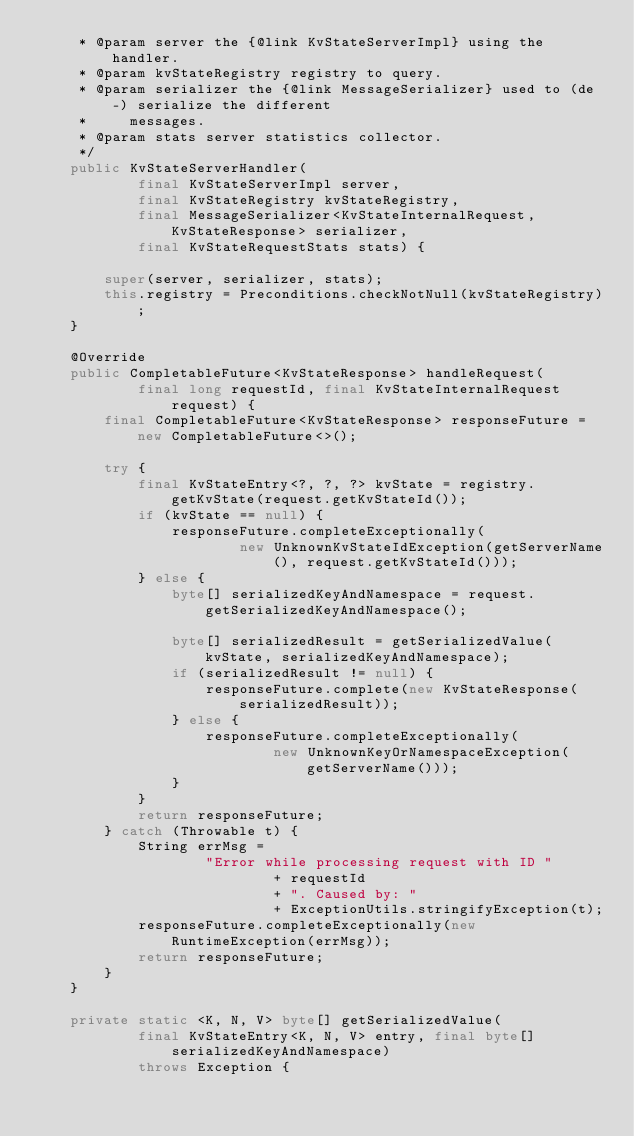<code> <loc_0><loc_0><loc_500><loc_500><_Java_>     * @param server the {@link KvStateServerImpl} using the handler.
     * @param kvStateRegistry registry to query.
     * @param serializer the {@link MessageSerializer} used to (de-) serialize the different
     *     messages.
     * @param stats server statistics collector.
     */
    public KvStateServerHandler(
            final KvStateServerImpl server,
            final KvStateRegistry kvStateRegistry,
            final MessageSerializer<KvStateInternalRequest, KvStateResponse> serializer,
            final KvStateRequestStats stats) {

        super(server, serializer, stats);
        this.registry = Preconditions.checkNotNull(kvStateRegistry);
    }

    @Override
    public CompletableFuture<KvStateResponse> handleRequest(
            final long requestId, final KvStateInternalRequest request) {
        final CompletableFuture<KvStateResponse> responseFuture = new CompletableFuture<>();

        try {
            final KvStateEntry<?, ?, ?> kvState = registry.getKvState(request.getKvStateId());
            if (kvState == null) {
                responseFuture.completeExceptionally(
                        new UnknownKvStateIdException(getServerName(), request.getKvStateId()));
            } else {
                byte[] serializedKeyAndNamespace = request.getSerializedKeyAndNamespace();

                byte[] serializedResult = getSerializedValue(kvState, serializedKeyAndNamespace);
                if (serializedResult != null) {
                    responseFuture.complete(new KvStateResponse(serializedResult));
                } else {
                    responseFuture.completeExceptionally(
                            new UnknownKeyOrNamespaceException(getServerName()));
                }
            }
            return responseFuture;
        } catch (Throwable t) {
            String errMsg =
                    "Error while processing request with ID "
                            + requestId
                            + ". Caused by: "
                            + ExceptionUtils.stringifyException(t);
            responseFuture.completeExceptionally(new RuntimeException(errMsg));
            return responseFuture;
        }
    }

    private static <K, N, V> byte[] getSerializedValue(
            final KvStateEntry<K, N, V> entry, final byte[] serializedKeyAndNamespace)
            throws Exception {
</code> 